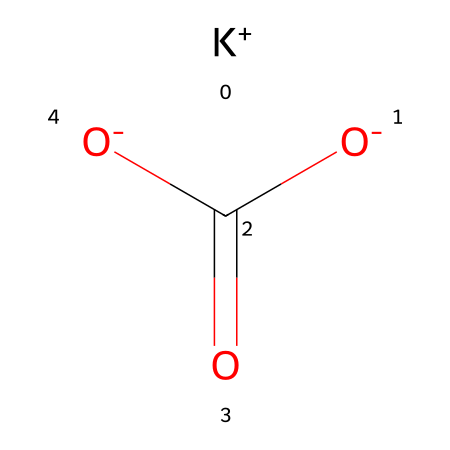What is the name of this chemical? The SMILES representation indicates it is potassium bicarbonate, composed of potassium ions (K+), bicarbonate ions (HCO3-), and has a distinctive structure.
Answer: potassium bicarbonate How many oxygen atoms are present in this molecule? The structure shows two oxygen atoms in the bicarbonate part (O=C(O)O) plus one oxygen in the potassium part (K+) making a total of three.
Answer: three What charge does the bicarbonate ion carry in this chemical? The bicarbonate ion contains one proton (H+) and has a net charge of negative one, represented by the O- in the structure.
Answer: negative one Is this compound an acid, base, or neutral? Potassium bicarbonate acts as a weak base when dissolved in water due to its bicarbonate ion, which can accept hydrogen ions.
Answer: weak base Does this chemical dissociate into electrolytes in solution? In aqueous solution, potassium bicarbonate dissociates into K+ and HCO3- ions, making it an electrolyte and conducting electricity.
Answer: yes What functional groups are present in this molecule? The structure shows a carboxylate group (-COO-) and an alkali metal (potassium), characteristic of bicarbonate.
Answer: carboxylate and alkali metal 